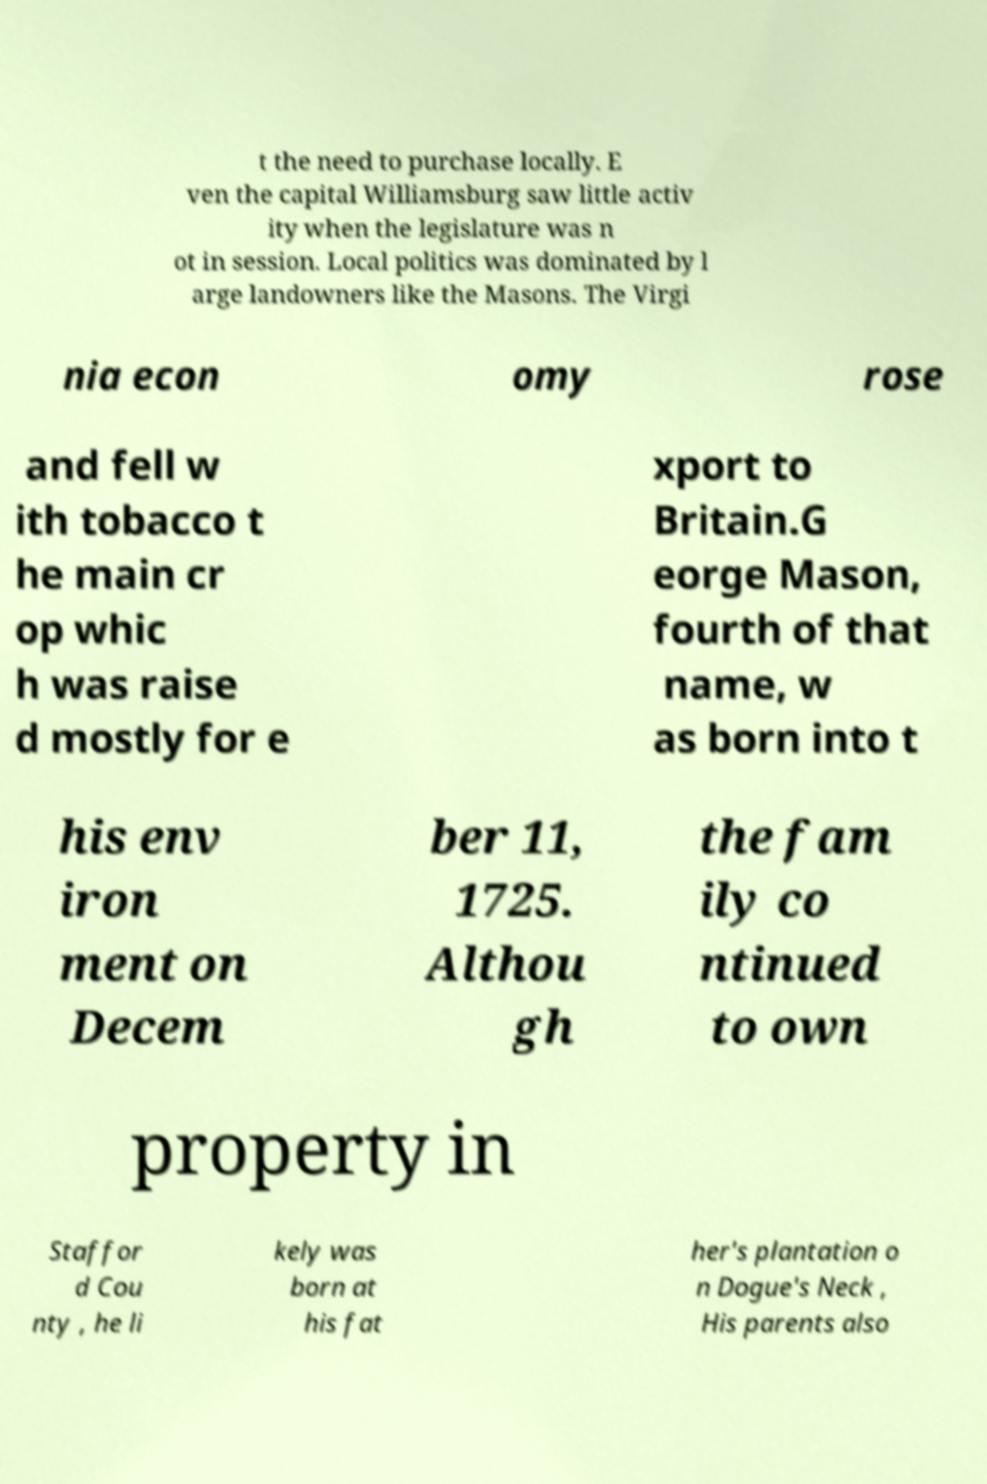I need the written content from this picture converted into text. Can you do that? t the need to purchase locally. E ven the capital Williamsburg saw little activ ity when the legislature was n ot in session. Local politics was dominated by l arge landowners like the Masons. The Virgi nia econ omy rose and fell w ith tobacco t he main cr op whic h was raise d mostly for e xport to Britain.G eorge Mason, fourth of that name, w as born into t his env iron ment on Decem ber 11, 1725. Althou gh the fam ily co ntinued to own property in Staffor d Cou nty , he li kely was born at his fat her's plantation o n Dogue's Neck , His parents also 